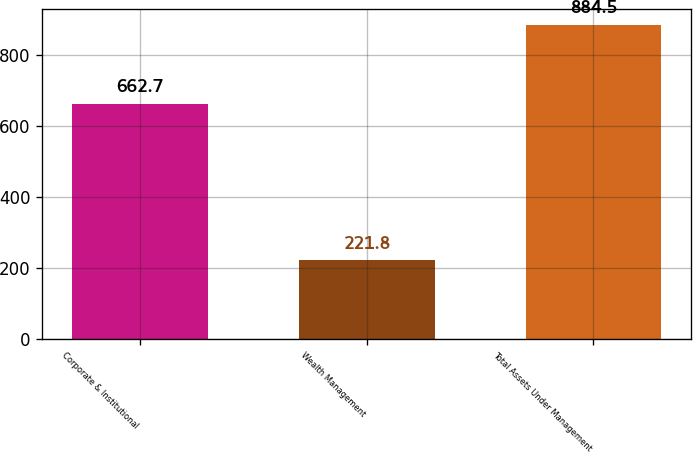<chart> <loc_0><loc_0><loc_500><loc_500><bar_chart><fcel>Corporate & Institutional<fcel>Wealth Management<fcel>Total Assets Under Management<nl><fcel>662.7<fcel>221.8<fcel>884.5<nl></chart> 